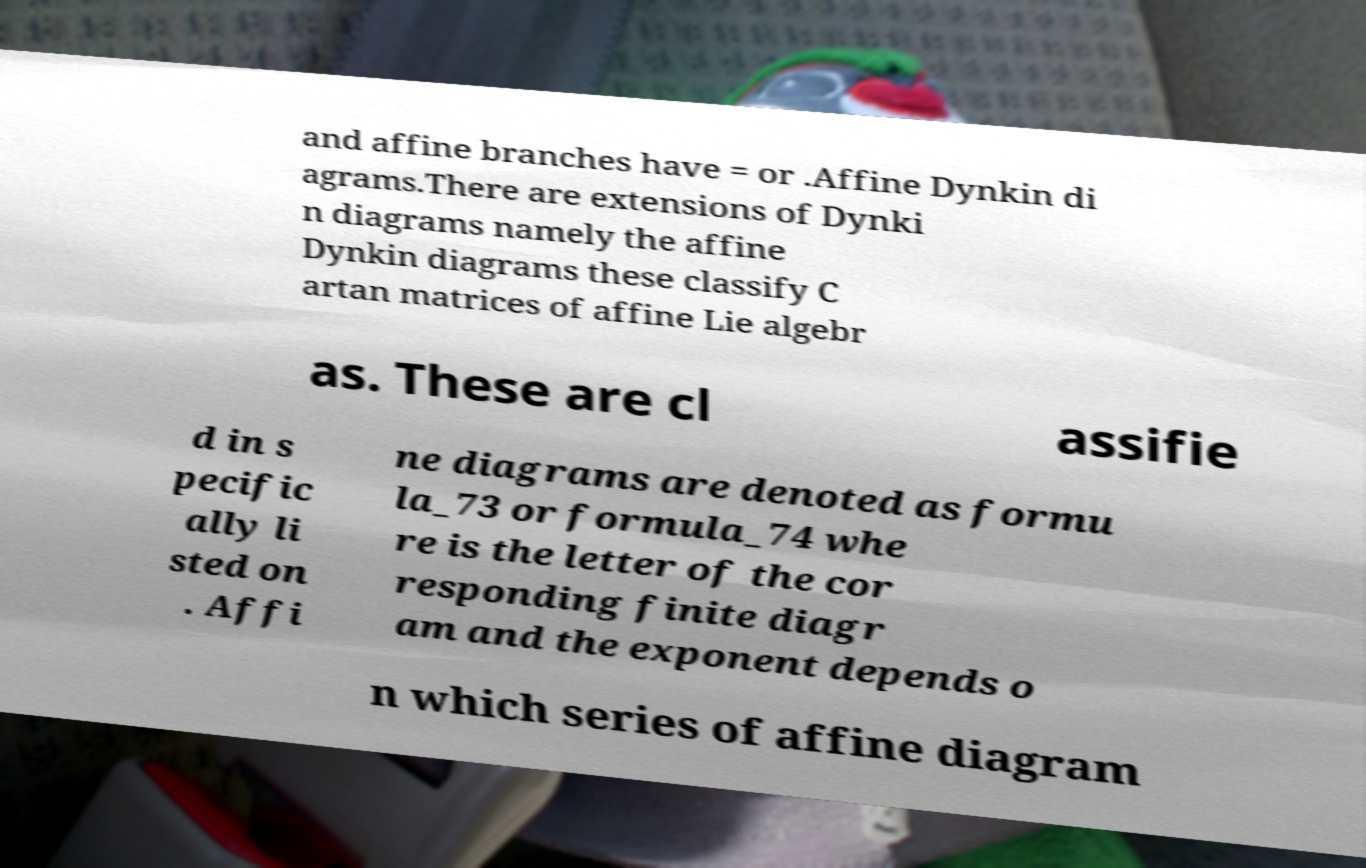What messages or text are displayed in this image? I need them in a readable, typed format. and affine branches have = or .Affine Dynkin di agrams.There are extensions of Dynki n diagrams namely the affine Dynkin diagrams these classify C artan matrices of affine Lie algebr as. These are cl assifie d in s pecific ally li sted on . Affi ne diagrams are denoted as formu la_73 or formula_74 whe re is the letter of the cor responding finite diagr am and the exponent depends o n which series of affine diagram 